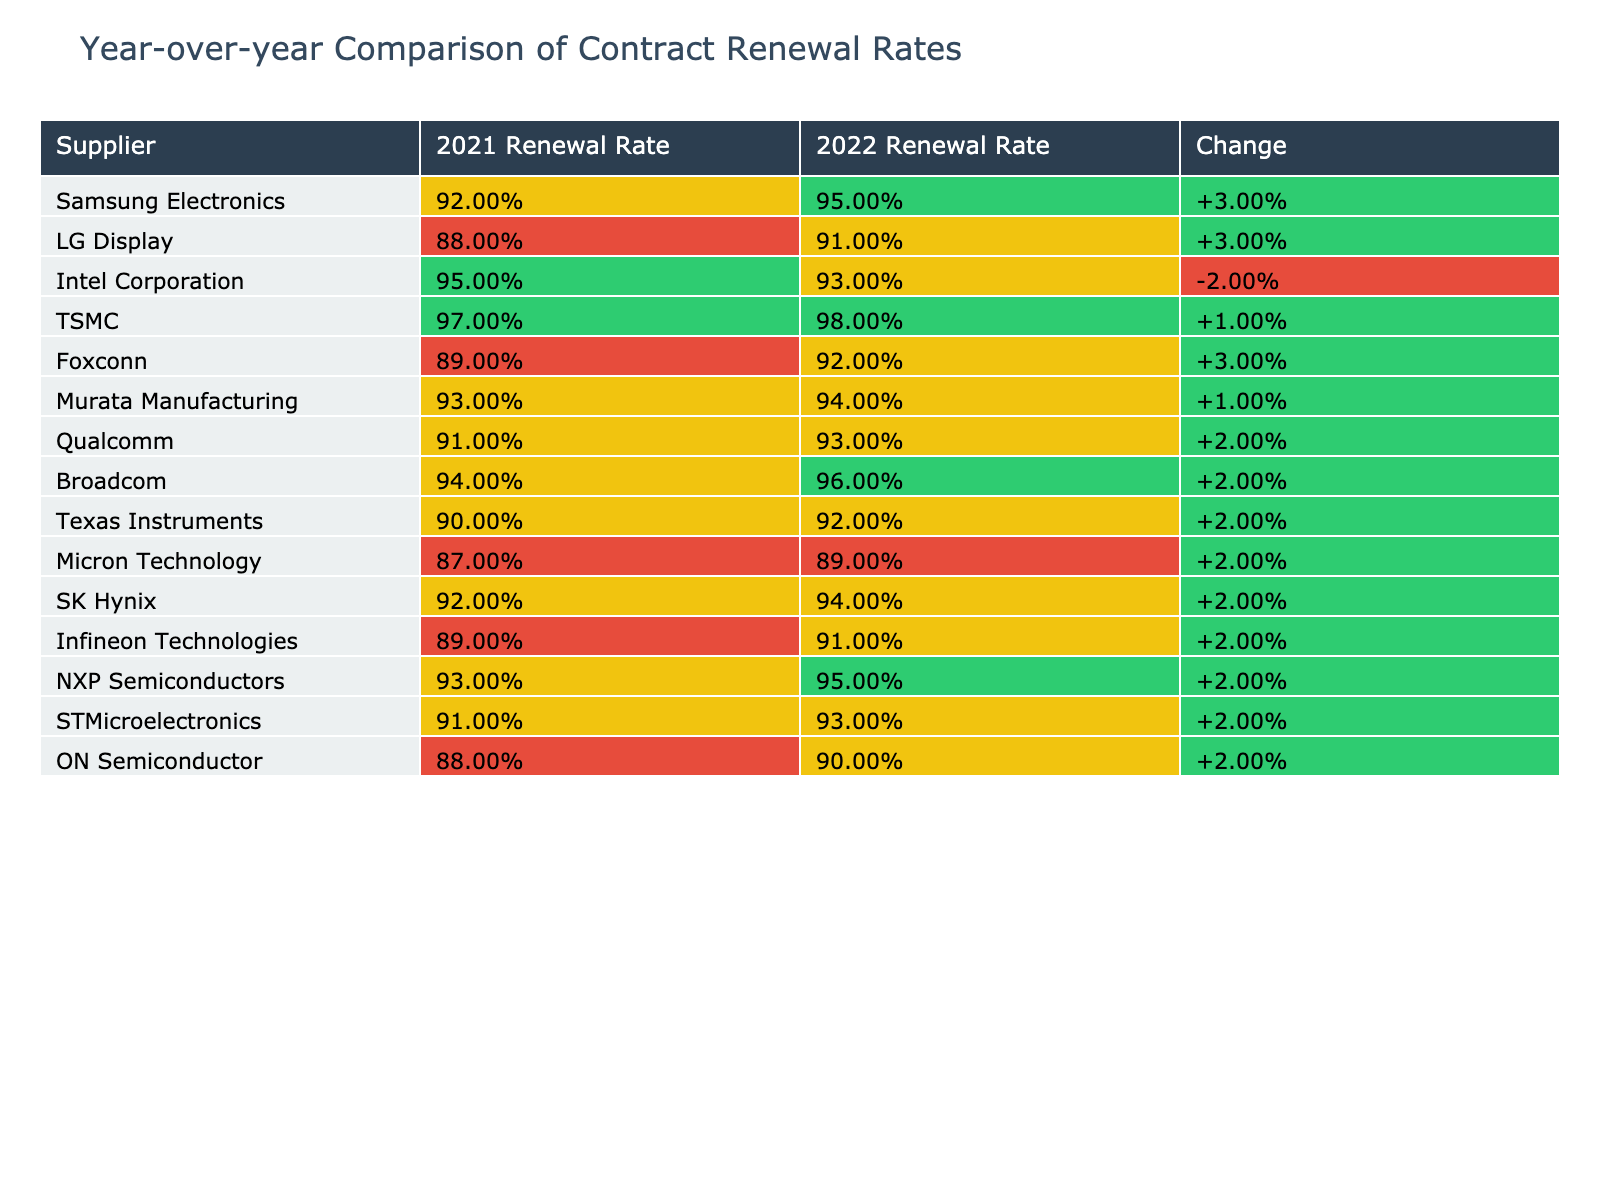What was the renewal rate for Samsung Electronics in 2022? The table shows that Samsung Electronics had a renewal rate of 95% in 2022.
Answer: 95% Which supplier had the highest renewal rate in 2021? By examining the 2021 renewal rates, TSMC had the highest rate at 97%.
Answer: TSMC What is the percentage change in renewal rate for Intel Corporation from 2021 to 2022? The renewal rate for Intel Corporation in 2021 was 95%, and in 2022 it was 93%. The change is calculated as 93% - 95% = -2%.
Answer: -2% Did Micron Technology improve its renewal rate from 2021 to 2022? Micron Technology had a renewal rate of 87% in 2021 and 89% in 2022. Since 89% is greater than 87%, it indicates an improvement.
Answer: Yes What is the average renewal rate for all suppliers in 2022? To find the average for 2022, we sum the renewal rates (95% + 91% + 93% + 98% + 92% + 94% + 93% + 96% + 92% + 89% + 94% + 91% + 95% + 93% + 90%) and divide by the number of suppliers, which is 15. The sum is 1396%, so the average is 1396% / 15 = 93.07%.
Answer: 93.07% Which supplier had the lowest renewal rate in 2021? Looking at the 2021 rates, Micron Technology had the lowest renewal rate at 87%.
Answer: Micron Technology How many suppliers maintained or improved their renewal rates from 2021 to 2022? By comparing the renewal rates of each supplier, we find that 10 suppliers maintained or improved their renewal rates (only 5 suppliers saw a decline).
Answer: 10 What is the total change in renewal rates across all suppliers from 2021 to 2022? To find the total change, we add the individual changes from the "Change" column. The total change calculated is -0.04 (indicating a slight decline overall).
Answer: -0.04 Which suppliers had changes in renewal rates less than 1% between 2021 and 2022? By checking the "Change" values, we find that Intel Corporation, Murata Manufacturing, Qualcomm, and ON Semiconductor all had changes within this range.
Answer: Intel Corporation, Murata Manufacturing, Qualcomm, ON Semiconductor What is the renewal rate for SK Hynix in 2022 compared to its 2021 rate? SK Hynix had a renewal rate of 92% in 2021 and increased it to 94% in 2022.
Answer: Increased Which two suppliers had the largest percentage increases in renewal rates? After comparing the changes, TSMC and Broadcom had the largest increases, at +1% and +2% respectively.
Answer: TSMC, Broadcom 